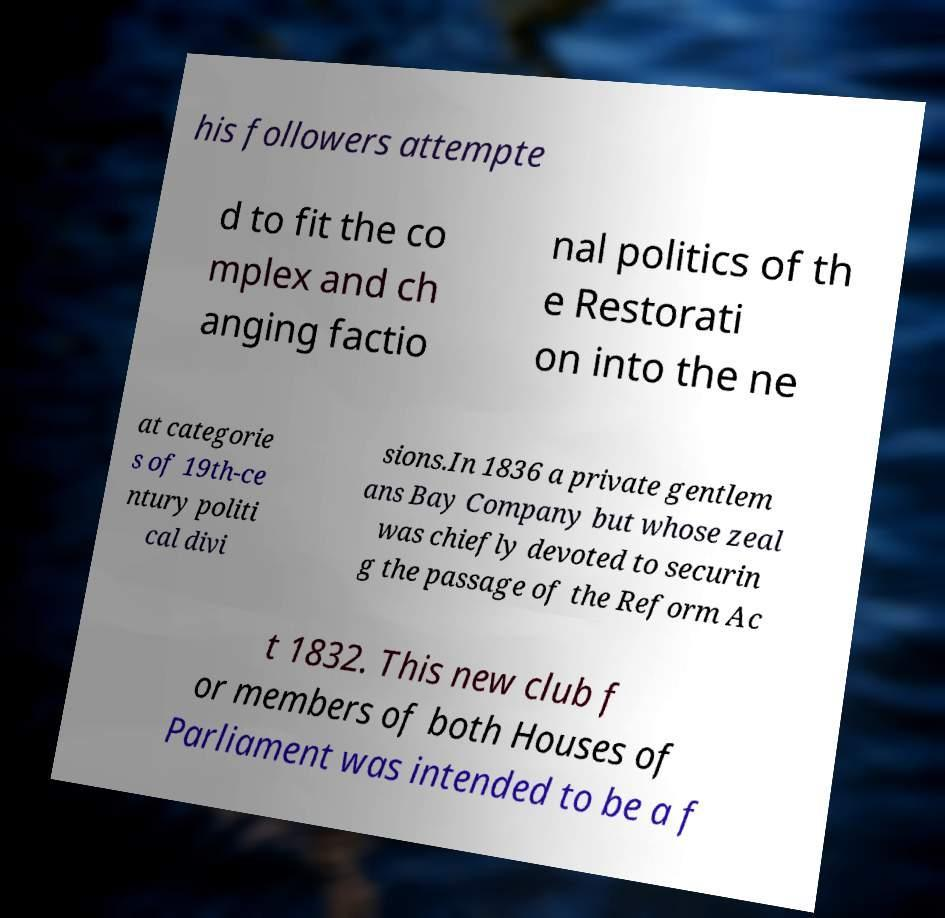For documentation purposes, I need the text within this image transcribed. Could you provide that? his followers attempte d to fit the co mplex and ch anging factio nal politics of th e Restorati on into the ne at categorie s of 19th-ce ntury politi cal divi sions.In 1836 a private gentlem ans Bay Company but whose zeal was chiefly devoted to securin g the passage of the Reform Ac t 1832. This new club f or members of both Houses of Parliament was intended to be a f 